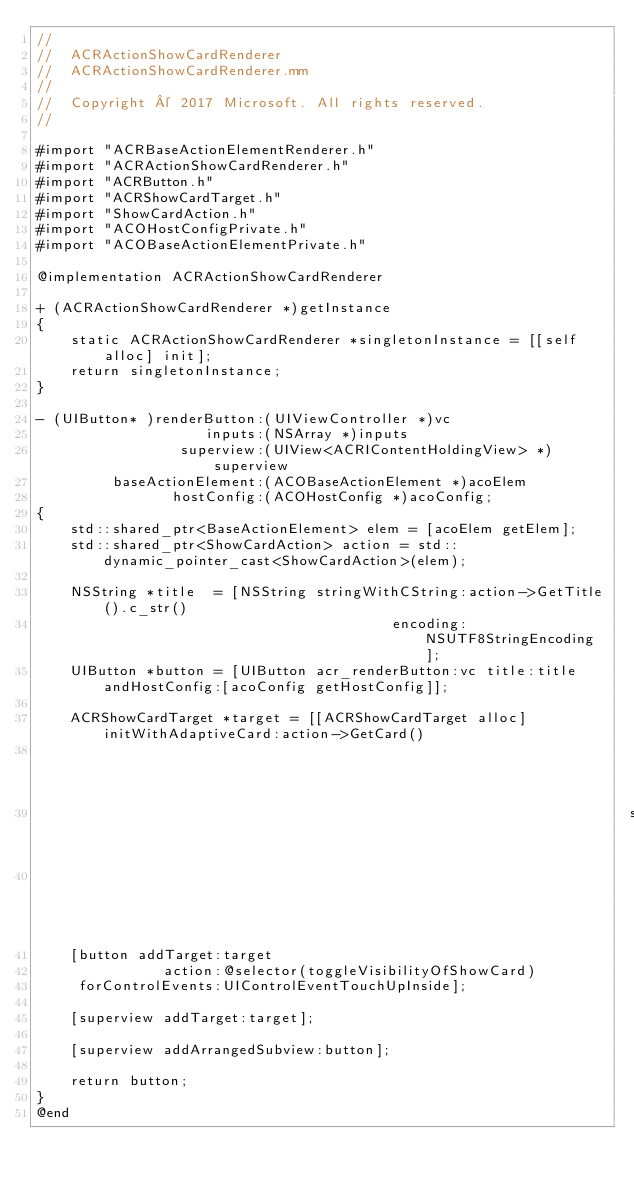<code> <loc_0><loc_0><loc_500><loc_500><_ObjectiveC_>//
//  ACRActionShowCardRenderer
//  ACRActionShowCardRenderer.mm
//
//  Copyright © 2017 Microsoft. All rights reserved.
//

#import "ACRBaseActionElementRenderer.h"
#import "ACRActionShowCardRenderer.h"
#import "ACRButton.h"
#import "ACRShowCardTarget.h"
#import "ShowCardAction.h"
#import "ACOHostConfigPrivate.h"
#import "ACOBaseActionElementPrivate.h"

@implementation ACRActionShowCardRenderer

+ (ACRActionShowCardRenderer *)getInstance
{
    static ACRActionShowCardRenderer *singletonInstance = [[self alloc] init];
    return singletonInstance;
}

- (UIButton* )renderButton:(UIViewController *)vc
                    inputs:(NSArray *)inputs
                 superview:(UIView<ACRIContentHoldingView> *)superview
         baseActionElement:(ACOBaseActionElement *)acoElem
                hostConfig:(ACOHostConfig *)acoConfig;
{
    std::shared_ptr<BaseActionElement> elem = [acoElem getElem];
    std::shared_ptr<ShowCardAction> action = std::dynamic_pointer_cast<ShowCardAction>(elem);

    NSString *title  = [NSString stringWithCString:action->GetTitle().c_str()
                                          encoding:NSUTF8StringEncoding];
    UIButton *button = [UIButton acr_renderButton:vc title:title andHostConfig:[acoConfig getHostConfig]];

    ACRShowCardTarget *target = [[ACRShowCardTarget alloc] initWithAdaptiveCard:action->GetCard()
                                                                         config:acoConfig
                                                                      superview:superview
                                                                             vc:vc];
    [button addTarget:target
               action:@selector(toggleVisibilityOfShowCard)
     forControlEvents:UIControlEventTouchUpInside];

    [superview addTarget:target];

    [superview addArrangedSubview:button];

    return button;
}
@end
</code> 